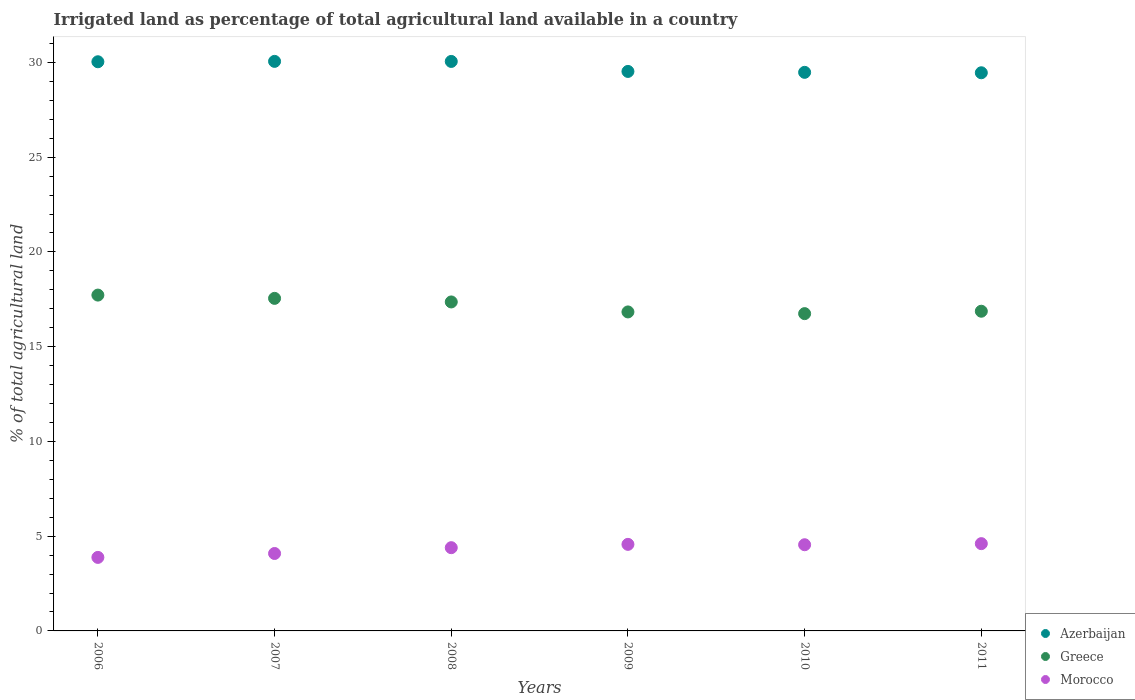How many different coloured dotlines are there?
Make the answer very short. 3. What is the percentage of irrigated land in Morocco in 2007?
Keep it short and to the point. 4.09. Across all years, what is the maximum percentage of irrigated land in Morocco?
Your answer should be compact. 4.61. Across all years, what is the minimum percentage of irrigated land in Azerbaijan?
Give a very brief answer. 29.45. In which year was the percentage of irrigated land in Morocco maximum?
Your response must be concise. 2011. What is the total percentage of irrigated land in Azerbaijan in the graph?
Make the answer very short. 178.6. What is the difference between the percentage of irrigated land in Azerbaijan in 2007 and that in 2008?
Your response must be concise. 0. What is the difference between the percentage of irrigated land in Azerbaijan in 2007 and the percentage of irrigated land in Morocco in 2010?
Make the answer very short. 25.51. What is the average percentage of irrigated land in Morocco per year?
Offer a terse response. 4.35. In the year 2006, what is the difference between the percentage of irrigated land in Azerbaijan and percentage of irrigated land in Morocco?
Make the answer very short. 26.16. In how many years, is the percentage of irrigated land in Azerbaijan greater than 12 %?
Make the answer very short. 6. What is the ratio of the percentage of irrigated land in Greece in 2006 to that in 2007?
Your response must be concise. 1.01. What is the difference between the highest and the second highest percentage of irrigated land in Azerbaijan?
Offer a very short reply. 0. What is the difference between the highest and the lowest percentage of irrigated land in Greece?
Your answer should be very brief. 0.98. Does the percentage of irrigated land in Greece monotonically increase over the years?
Offer a very short reply. No. How many dotlines are there?
Your answer should be very brief. 3. What is the difference between two consecutive major ticks on the Y-axis?
Provide a short and direct response. 5. Are the values on the major ticks of Y-axis written in scientific E-notation?
Offer a very short reply. No. Does the graph contain any zero values?
Keep it short and to the point. No. Where does the legend appear in the graph?
Make the answer very short. Bottom right. How many legend labels are there?
Give a very brief answer. 3. How are the legend labels stacked?
Ensure brevity in your answer.  Vertical. What is the title of the graph?
Make the answer very short. Irrigated land as percentage of total agricultural land available in a country. Does "Bolivia" appear as one of the legend labels in the graph?
Keep it short and to the point. No. What is the label or title of the X-axis?
Ensure brevity in your answer.  Years. What is the label or title of the Y-axis?
Ensure brevity in your answer.  % of total agricultural land. What is the % of total agricultural land of Azerbaijan in 2006?
Provide a succinct answer. 30.04. What is the % of total agricultural land of Greece in 2006?
Offer a terse response. 17.72. What is the % of total agricultural land in Morocco in 2006?
Make the answer very short. 3.88. What is the % of total agricultural land of Azerbaijan in 2007?
Provide a short and direct response. 30.06. What is the % of total agricultural land of Greece in 2007?
Offer a very short reply. 17.55. What is the % of total agricultural land of Morocco in 2007?
Give a very brief answer. 4.09. What is the % of total agricultural land of Azerbaijan in 2008?
Your answer should be compact. 30.05. What is the % of total agricultural land of Greece in 2008?
Keep it short and to the point. 17.36. What is the % of total agricultural land in Morocco in 2008?
Offer a very short reply. 4.39. What is the % of total agricultural land in Azerbaijan in 2009?
Offer a terse response. 29.53. What is the % of total agricultural land of Greece in 2009?
Give a very brief answer. 16.83. What is the % of total agricultural land of Morocco in 2009?
Offer a very short reply. 4.57. What is the % of total agricultural land of Azerbaijan in 2010?
Your answer should be very brief. 29.48. What is the % of total agricultural land of Greece in 2010?
Your answer should be compact. 16.74. What is the % of total agricultural land in Morocco in 2010?
Your answer should be very brief. 4.55. What is the % of total agricultural land of Azerbaijan in 2011?
Your answer should be compact. 29.45. What is the % of total agricultural land of Greece in 2011?
Your response must be concise. 16.87. What is the % of total agricultural land in Morocco in 2011?
Provide a short and direct response. 4.61. Across all years, what is the maximum % of total agricultural land in Azerbaijan?
Offer a very short reply. 30.06. Across all years, what is the maximum % of total agricultural land in Greece?
Provide a succinct answer. 17.72. Across all years, what is the maximum % of total agricultural land in Morocco?
Provide a succinct answer. 4.61. Across all years, what is the minimum % of total agricultural land in Azerbaijan?
Ensure brevity in your answer.  29.45. Across all years, what is the minimum % of total agricultural land in Greece?
Provide a short and direct response. 16.74. Across all years, what is the minimum % of total agricultural land in Morocco?
Provide a succinct answer. 3.88. What is the total % of total agricultural land of Azerbaijan in the graph?
Offer a terse response. 178.6. What is the total % of total agricultural land in Greece in the graph?
Provide a short and direct response. 103.08. What is the total % of total agricultural land of Morocco in the graph?
Offer a very short reply. 26.08. What is the difference between the % of total agricultural land in Azerbaijan in 2006 and that in 2007?
Your answer should be very brief. -0.02. What is the difference between the % of total agricultural land of Greece in 2006 and that in 2007?
Keep it short and to the point. 0.17. What is the difference between the % of total agricultural land of Morocco in 2006 and that in 2007?
Ensure brevity in your answer.  -0.21. What is the difference between the % of total agricultural land of Azerbaijan in 2006 and that in 2008?
Provide a succinct answer. -0.02. What is the difference between the % of total agricultural land in Greece in 2006 and that in 2008?
Ensure brevity in your answer.  0.36. What is the difference between the % of total agricultural land of Morocco in 2006 and that in 2008?
Keep it short and to the point. -0.51. What is the difference between the % of total agricultural land of Azerbaijan in 2006 and that in 2009?
Your answer should be very brief. 0.51. What is the difference between the % of total agricultural land of Greece in 2006 and that in 2009?
Provide a succinct answer. 0.89. What is the difference between the % of total agricultural land of Morocco in 2006 and that in 2009?
Your answer should be compact. -0.69. What is the difference between the % of total agricultural land in Azerbaijan in 2006 and that in 2010?
Your answer should be compact. 0.56. What is the difference between the % of total agricultural land of Greece in 2006 and that in 2010?
Provide a short and direct response. 0.98. What is the difference between the % of total agricultural land of Morocco in 2006 and that in 2010?
Make the answer very short. -0.67. What is the difference between the % of total agricultural land in Azerbaijan in 2006 and that in 2011?
Provide a short and direct response. 0.58. What is the difference between the % of total agricultural land in Greece in 2006 and that in 2011?
Offer a terse response. 0.85. What is the difference between the % of total agricultural land in Morocco in 2006 and that in 2011?
Your answer should be compact. -0.73. What is the difference between the % of total agricultural land of Azerbaijan in 2007 and that in 2008?
Provide a succinct answer. 0. What is the difference between the % of total agricultural land of Greece in 2007 and that in 2008?
Provide a succinct answer. 0.19. What is the difference between the % of total agricultural land in Morocco in 2007 and that in 2008?
Provide a short and direct response. -0.31. What is the difference between the % of total agricultural land of Azerbaijan in 2007 and that in 2009?
Ensure brevity in your answer.  0.53. What is the difference between the % of total agricultural land in Greece in 2007 and that in 2009?
Give a very brief answer. 0.72. What is the difference between the % of total agricultural land of Morocco in 2007 and that in 2009?
Make the answer very short. -0.48. What is the difference between the % of total agricultural land of Azerbaijan in 2007 and that in 2010?
Offer a very short reply. 0.58. What is the difference between the % of total agricultural land of Greece in 2007 and that in 2010?
Offer a terse response. 0.81. What is the difference between the % of total agricultural land in Morocco in 2007 and that in 2010?
Offer a terse response. -0.46. What is the difference between the % of total agricultural land of Azerbaijan in 2007 and that in 2011?
Your answer should be very brief. 0.6. What is the difference between the % of total agricultural land in Greece in 2007 and that in 2011?
Your answer should be very brief. 0.68. What is the difference between the % of total agricultural land in Morocco in 2007 and that in 2011?
Provide a succinct answer. -0.52. What is the difference between the % of total agricultural land in Azerbaijan in 2008 and that in 2009?
Make the answer very short. 0.53. What is the difference between the % of total agricultural land of Greece in 2008 and that in 2009?
Keep it short and to the point. 0.53. What is the difference between the % of total agricultural land of Morocco in 2008 and that in 2009?
Keep it short and to the point. -0.18. What is the difference between the % of total agricultural land in Azerbaijan in 2008 and that in 2010?
Provide a short and direct response. 0.58. What is the difference between the % of total agricultural land in Greece in 2008 and that in 2010?
Your response must be concise. 0.62. What is the difference between the % of total agricultural land in Morocco in 2008 and that in 2010?
Keep it short and to the point. -0.16. What is the difference between the % of total agricultural land of Azerbaijan in 2008 and that in 2011?
Your answer should be very brief. 0.6. What is the difference between the % of total agricultural land in Greece in 2008 and that in 2011?
Your answer should be very brief. 0.49. What is the difference between the % of total agricultural land in Morocco in 2008 and that in 2011?
Offer a very short reply. -0.21. What is the difference between the % of total agricultural land of Azerbaijan in 2009 and that in 2010?
Your response must be concise. 0.05. What is the difference between the % of total agricultural land in Greece in 2009 and that in 2010?
Give a very brief answer. 0.09. What is the difference between the % of total agricultural land in Morocco in 2009 and that in 2010?
Offer a terse response. 0.02. What is the difference between the % of total agricultural land of Azerbaijan in 2009 and that in 2011?
Give a very brief answer. 0.07. What is the difference between the % of total agricultural land of Greece in 2009 and that in 2011?
Keep it short and to the point. -0.04. What is the difference between the % of total agricultural land of Morocco in 2009 and that in 2011?
Your answer should be very brief. -0.04. What is the difference between the % of total agricultural land of Azerbaijan in 2010 and that in 2011?
Keep it short and to the point. 0.02. What is the difference between the % of total agricultural land of Greece in 2010 and that in 2011?
Ensure brevity in your answer.  -0.13. What is the difference between the % of total agricultural land in Morocco in 2010 and that in 2011?
Give a very brief answer. -0.06. What is the difference between the % of total agricultural land of Azerbaijan in 2006 and the % of total agricultural land of Greece in 2007?
Provide a succinct answer. 12.49. What is the difference between the % of total agricultural land of Azerbaijan in 2006 and the % of total agricultural land of Morocco in 2007?
Your response must be concise. 25.95. What is the difference between the % of total agricultural land in Greece in 2006 and the % of total agricultural land in Morocco in 2007?
Your answer should be compact. 13.64. What is the difference between the % of total agricultural land in Azerbaijan in 2006 and the % of total agricultural land in Greece in 2008?
Give a very brief answer. 12.68. What is the difference between the % of total agricultural land in Azerbaijan in 2006 and the % of total agricultural land in Morocco in 2008?
Make the answer very short. 25.64. What is the difference between the % of total agricultural land of Greece in 2006 and the % of total agricultural land of Morocco in 2008?
Ensure brevity in your answer.  13.33. What is the difference between the % of total agricultural land in Azerbaijan in 2006 and the % of total agricultural land in Greece in 2009?
Offer a terse response. 13.2. What is the difference between the % of total agricultural land in Azerbaijan in 2006 and the % of total agricultural land in Morocco in 2009?
Offer a terse response. 25.47. What is the difference between the % of total agricultural land of Greece in 2006 and the % of total agricultural land of Morocco in 2009?
Your response must be concise. 13.15. What is the difference between the % of total agricultural land of Azerbaijan in 2006 and the % of total agricultural land of Greece in 2010?
Keep it short and to the point. 13.29. What is the difference between the % of total agricultural land of Azerbaijan in 2006 and the % of total agricultural land of Morocco in 2010?
Your answer should be very brief. 25.49. What is the difference between the % of total agricultural land of Greece in 2006 and the % of total agricultural land of Morocco in 2010?
Your response must be concise. 13.17. What is the difference between the % of total agricultural land in Azerbaijan in 2006 and the % of total agricultural land in Greece in 2011?
Your answer should be compact. 13.17. What is the difference between the % of total agricultural land in Azerbaijan in 2006 and the % of total agricultural land in Morocco in 2011?
Ensure brevity in your answer.  25.43. What is the difference between the % of total agricultural land in Greece in 2006 and the % of total agricultural land in Morocco in 2011?
Your answer should be compact. 13.12. What is the difference between the % of total agricultural land of Azerbaijan in 2007 and the % of total agricultural land of Greece in 2008?
Your answer should be very brief. 12.7. What is the difference between the % of total agricultural land in Azerbaijan in 2007 and the % of total agricultural land in Morocco in 2008?
Keep it short and to the point. 25.66. What is the difference between the % of total agricultural land of Greece in 2007 and the % of total agricultural land of Morocco in 2008?
Offer a terse response. 13.16. What is the difference between the % of total agricultural land in Azerbaijan in 2007 and the % of total agricultural land in Greece in 2009?
Ensure brevity in your answer.  13.22. What is the difference between the % of total agricultural land in Azerbaijan in 2007 and the % of total agricultural land in Morocco in 2009?
Offer a very short reply. 25.49. What is the difference between the % of total agricultural land in Greece in 2007 and the % of total agricultural land in Morocco in 2009?
Your answer should be very brief. 12.98. What is the difference between the % of total agricultural land of Azerbaijan in 2007 and the % of total agricultural land of Greece in 2010?
Offer a very short reply. 13.31. What is the difference between the % of total agricultural land in Azerbaijan in 2007 and the % of total agricultural land in Morocco in 2010?
Give a very brief answer. 25.51. What is the difference between the % of total agricultural land of Greece in 2007 and the % of total agricultural land of Morocco in 2010?
Your answer should be compact. 13. What is the difference between the % of total agricultural land of Azerbaijan in 2007 and the % of total agricultural land of Greece in 2011?
Keep it short and to the point. 13.19. What is the difference between the % of total agricultural land of Azerbaijan in 2007 and the % of total agricultural land of Morocco in 2011?
Make the answer very short. 25.45. What is the difference between the % of total agricultural land of Greece in 2007 and the % of total agricultural land of Morocco in 2011?
Your response must be concise. 12.94. What is the difference between the % of total agricultural land in Azerbaijan in 2008 and the % of total agricultural land in Greece in 2009?
Give a very brief answer. 13.22. What is the difference between the % of total agricultural land of Azerbaijan in 2008 and the % of total agricultural land of Morocco in 2009?
Your answer should be compact. 25.48. What is the difference between the % of total agricultural land in Greece in 2008 and the % of total agricultural land in Morocco in 2009?
Give a very brief answer. 12.79. What is the difference between the % of total agricultural land of Azerbaijan in 2008 and the % of total agricultural land of Greece in 2010?
Ensure brevity in your answer.  13.31. What is the difference between the % of total agricultural land in Azerbaijan in 2008 and the % of total agricultural land in Morocco in 2010?
Your answer should be very brief. 25.5. What is the difference between the % of total agricultural land of Greece in 2008 and the % of total agricultural land of Morocco in 2010?
Offer a terse response. 12.81. What is the difference between the % of total agricultural land of Azerbaijan in 2008 and the % of total agricultural land of Greece in 2011?
Offer a terse response. 13.18. What is the difference between the % of total agricultural land in Azerbaijan in 2008 and the % of total agricultural land in Morocco in 2011?
Offer a terse response. 25.45. What is the difference between the % of total agricultural land in Greece in 2008 and the % of total agricultural land in Morocco in 2011?
Offer a very short reply. 12.75. What is the difference between the % of total agricultural land of Azerbaijan in 2009 and the % of total agricultural land of Greece in 2010?
Ensure brevity in your answer.  12.78. What is the difference between the % of total agricultural land in Azerbaijan in 2009 and the % of total agricultural land in Morocco in 2010?
Keep it short and to the point. 24.98. What is the difference between the % of total agricultural land of Greece in 2009 and the % of total agricultural land of Morocco in 2010?
Your answer should be compact. 12.29. What is the difference between the % of total agricultural land of Azerbaijan in 2009 and the % of total agricultural land of Greece in 2011?
Ensure brevity in your answer.  12.65. What is the difference between the % of total agricultural land of Azerbaijan in 2009 and the % of total agricultural land of Morocco in 2011?
Your answer should be very brief. 24.92. What is the difference between the % of total agricultural land in Greece in 2009 and the % of total agricultural land in Morocco in 2011?
Your answer should be very brief. 12.23. What is the difference between the % of total agricultural land in Azerbaijan in 2010 and the % of total agricultural land in Greece in 2011?
Your answer should be very brief. 12.61. What is the difference between the % of total agricultural land in Azerbaijan in 2010 and the % of total agricultural land in Morocco in 2011?
Give a very brief answer. 24.87. What is the difference between the % of total agricultural land of Greece in 2010 and the % of total agricultural land of Morocco in 2011?
Keep it short and to the point. 12.14. What is the average % of total agricultural land in Azerbaijan per year?
Provide a succinct answer. 29.77. What is the average % of total agricultural land of Greece per year?
Your answer should be compact. 17.18. What is the average % of total agricultural land of Morocco per year?
Keep it short and to the point. 4.35. In the year 2006, what is the difference between the % of total agricultural land in Azerbaijan and % of total agricultural land in Greece?
Give a very brief answer. 12.31. In the year 2006, what is the difference between the % of total agricultural land of Azerbaijan and % of total agricultural land of Morocco?
Your response must be concise. 26.16. In the year 2006, what is the difference between the % of total agricultural land in Greece and % of total agricultural land in Morocco?
Provide a succinct answer. 13.84. In the year 2007, what is the difference between the % of total agricultural land of Azerbaijan and % of total agricultural land of Greece?
Offer a very short reply. 12.51. In the year 2007, what is the difference between the % of total agricultural land in Azerbaijan and % of total agricultural land in Morocco?
Your answer should be compact. 25.97. In the year 2007, what is the difference between the % of total agricultural land in Greece and % of total agricultural land in Morocco?
Your answer should be very brief. 13.46. In the year 2008, what is the difference between the % of total agricultural land of Azerbaijan and % of total agricultural land of Greece?
Your answer should be very brief. 12.69. In the year 2008, what is the difference between the % of total agricultural land of Azerbaijan and % of total agricultural land of Morocco?
Give a very brief answer. 25.66. In the year 2008, what is the difference between the % of total agricultural land of Greece and % of total agricultural land of Morocco?
Keep it short and to the point. 12.97. In the year 2009, what is the difference between the % of total agricultural land in Azerbaijan and % of total agricultural land in Greece?
Provide a short and direct response. 12.69. In the year 2009, what is the difference between the % of total agricultural land in Azerbaijan and % of total agricultural land in Morocco?
Offer a terse response. 24.96. In the year 2009, what is the difference between the % of total agricultural land of Greece and % of total agricultural land of Morocco?
Make the answer very short. 12.27. In the year 2010, what is the difference between the % of total agricultural land in Azerbaijan and % of total agricultural land in Greece?
Your answer should be very brief. 12.73. In the year 2010, what is the difference between the % of total agricultural land of Azerbaijan and % of total agricultural land of Morocco?
Give a very brief answer. 24.93. In the year 2010, what is the difference between the % of total agricultural land of Greece and % of total agricultural land of Morocco?
Provide a short and direct response. 12.2. In the year 2011, what is the difference between the % of total agricultural land in Azerbaijan and % of total agricultural land in Greece?
Your answer should be very brief. 12.58. In the year 2011, what is the difference between the % of total agricultural land of Azerbaijan and % of total agricultural land of Morocco?
Your response must be concise. 24.85. In the year 2011, what is the difference between the % of total agricultural land in Greece and % of total agricultural land in Morocco?
Make the answer very short. 12.26. What is the ratio of the % of total agricultural land of Greece in 2006 to that in 2007?
Your response must be concise. 1.01. What is the ratio of the % of total agricultural land in Morocco in 2006 to that in 2007?
Keep it short and to the point. 0.95. What is the ratio of the % of total agricultural land of Azerbaijan in 2006 to that in 2008?
Keep it short and to the point. 1. What is the ratio of the % of total agricultural land of Greece in 2006 to that in 2008?
Keep it short and to the point. 1.02. What is the ratio of the % of total agricultural land in Morocco in 2006 to that in 2008?
Ensure brevity in your answer.  0.88. What is the ratio of the % of total agricultural land in Azerbaijan in 2006 to that in 2009?
Your answer should be compact. 1.02. What is the ratio of the % of total agricultural land in Greece in 2006 to that in 2009?
Provide a short and direct response. 1.05. What is the ratio of the % of total agricultural land in Morocco in 2006 to that in 2009?
Your answer should be very brief. 0.85. What is the ratio of the % of total agricultural land of Azerbaijan in 2006 to that in 2010?
Offer a terse response. 1.02. What is the ratio of the % of total agricultural land of Greece in 2006 to that in 2010?
Keep it short and to the point. 1.06. What is the ratio of the % of total agricultural land of Morocco in 2006 to that in 2010?
Your answer should be very brief. 0.85. What is the ratio of the % of total agricultural land in Azerbaijan in 2006 to that in 2011?
Your answer should be very brief. 1.02. What is the ratio of the % of total agricultural land of Greece in 2006 to that in 2011?
Offer a very short reply. 1.05. What is the ratio of the % of total agricultural land in Morocco in 2006 to that in 2011?
Give a very brief answer. 0.84. What is the ratio of the % of total agricultural land in Azerbaijan in 2007 to that in 2008?
Offer a very short reply. 1. What is the ratio of the % of total agricultural land in Greece in 2007 to that in 2008?
Ensure brevity in your answer.  1.01. What is the ratio of the % of total agricultural land of Morocco in 2007 to that in 2008?
Make the answer very short. 0.93. What is the ratio of the % of total agricultural land of Greece in 2007 to that in 2009?
Make the answer very short. 1.04. What is the ratio of the % of total agricultural land of Morocco in 2007 to that in 2009?
Provide a short and direct response. 0.89. What is the ratio of the % of total agricultural land of Azerbaijan in 2007 to that in 2010?
Provide a succinct answer. 1.02. What is the ratio of the % of total agricultural land of Greece in 2007 to that in 2010?
Provide a short and direct response. 1.05. What is the ratio of the % of total agricultural land in Morocco in 2007 to that in 2010?
Your answer should be very brief. 0.9. What is the ratio of the % of total agricultural land of Azerbaijan in 2007 to that in 2011?
Provide a succinct answer. 1.02. What is the ratio of the % of total agricultural land in Greece in 2007 to that in 2011?
Your answer should be very brief. 1.04. What is the ratio of the % of total agricultural land in Morocco in 2007 to that in 2011?
Your response must be concise. 0.89. What is the ratio of the % of total agricultural land in Azerbaijan in 2008 to that in 2009?
Make the answer very short. 1.02. What is the ratio of the % of total agricultural land of Greece in 2008 to that in 2009?
Provide a succinct answer. 1.03. What is the ratio of the % of total agricultural land in Morocco in 2008 to that in 2009?
Make the answer very short. 0.96. What is the ratio of the % of total agricultural land in Azerbaijan in 2008 to that in 2010?
Your answer should be very brief. 1.02. What is the ratio of the % of total agricultural land in Greece in 2008 to that in 2010?
Offer a terse response. 1.04. What is the ratio of the % of total agricultural land in Morocco in 2008 to that in 2010?
Your answer should be very brief. 0.97. What is the ratio of the % of total agricultural land in Azerbaijan in 2008 to that in 2011?
Your response must be concise. 1.02. What is the ratio of the % of total agricultural land of Greece in 2008 to that in 2011?
Your response must be concise. 1.03. What is the ratio of the % of total agricultural land in Morocco in 2008 to that in 2011?
Offer a very short reply. 0.95. What is the ratio of the % of total agricultural land of Azerbaijan in 2009 to that in 2010?
Provide a succinct answer. 1. What is the ratio of the % of total agricultural land of Greece in 2009 to that in 2010?
Your answer should be very brief. 1.01. What is the ratio of the % of total agricultural land of Morocco in 2009 to that in 2011?
Make the answer very short. 0.99. What is the ratio of the % of total agricultural land of Azerbaijan in 2010 to that in 2011?
Offer a very short reply. 1. What is the ratio of the % of total agricultural land in Morocco in 2010 to that in 2011?
Make the answer very short. 0.99. What is the difference between the highest and the second highest % of total agricultural land of Azerbaijan?
Keep it short and to the point. 0. What is the difference between the highest and the second highest % of total agricultural land in Greece?
Keep it short and to the point. 0.17. What is the difference between the highest and the second highest % of total agricultural land of Morocco?
Offer a terse response. 0.04. What is the difference between the highest and the lowest % of total agricultural land in Azerbaijan?
Keep it short and to the point. 0.6. What is the difference between the highest and the lowest % of total agricultural land of Greece?
Give a very brief answer. 0.98. What is the difference between the highest and the lowest % of total agricultural land in Morocco?
Offer a very short reply. 0.73. 